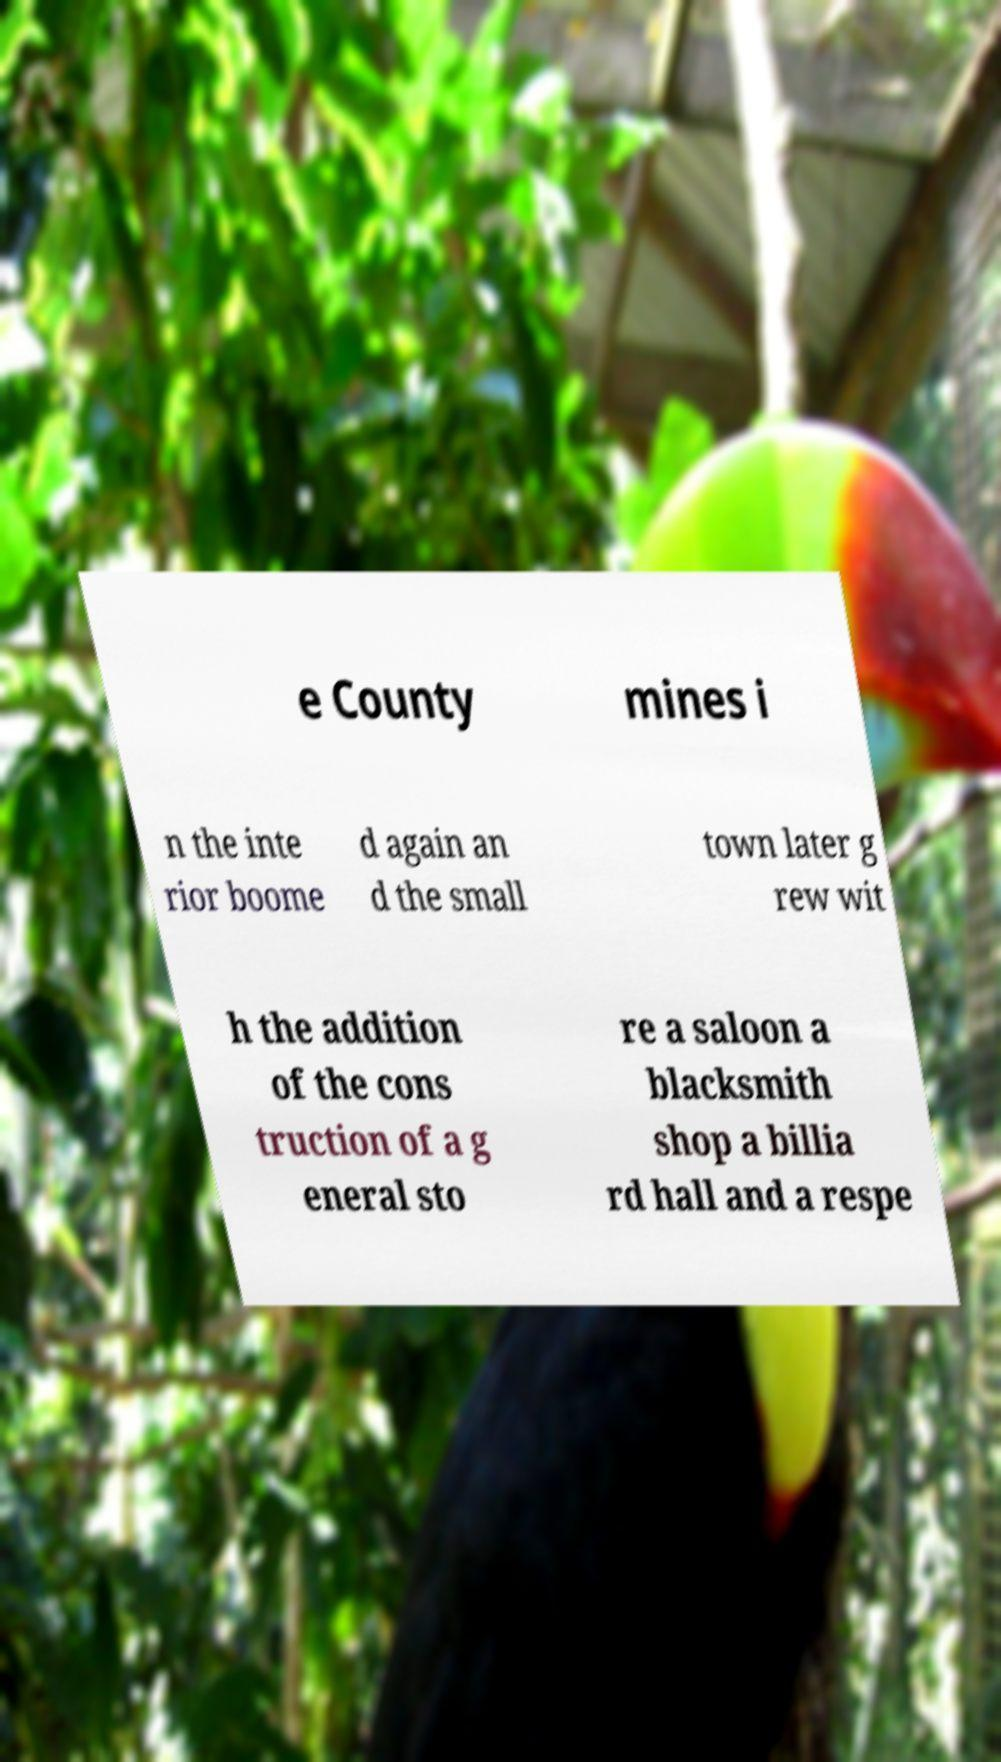Can you read and provide the text displayed in the image?This photo seems to have some interesting text. Can you extract and type it out for me? e County mines i n the inte rior boome d again an d the small town later g rew wit h the addition of the cons truction of a g eneral sto re a saloon a blacksmith shop a billia rd hall and a respe 